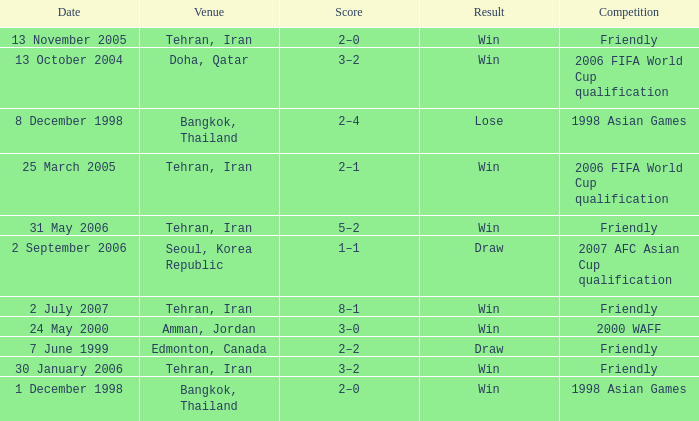What was the competition on 7 June 1999? Friendly. 